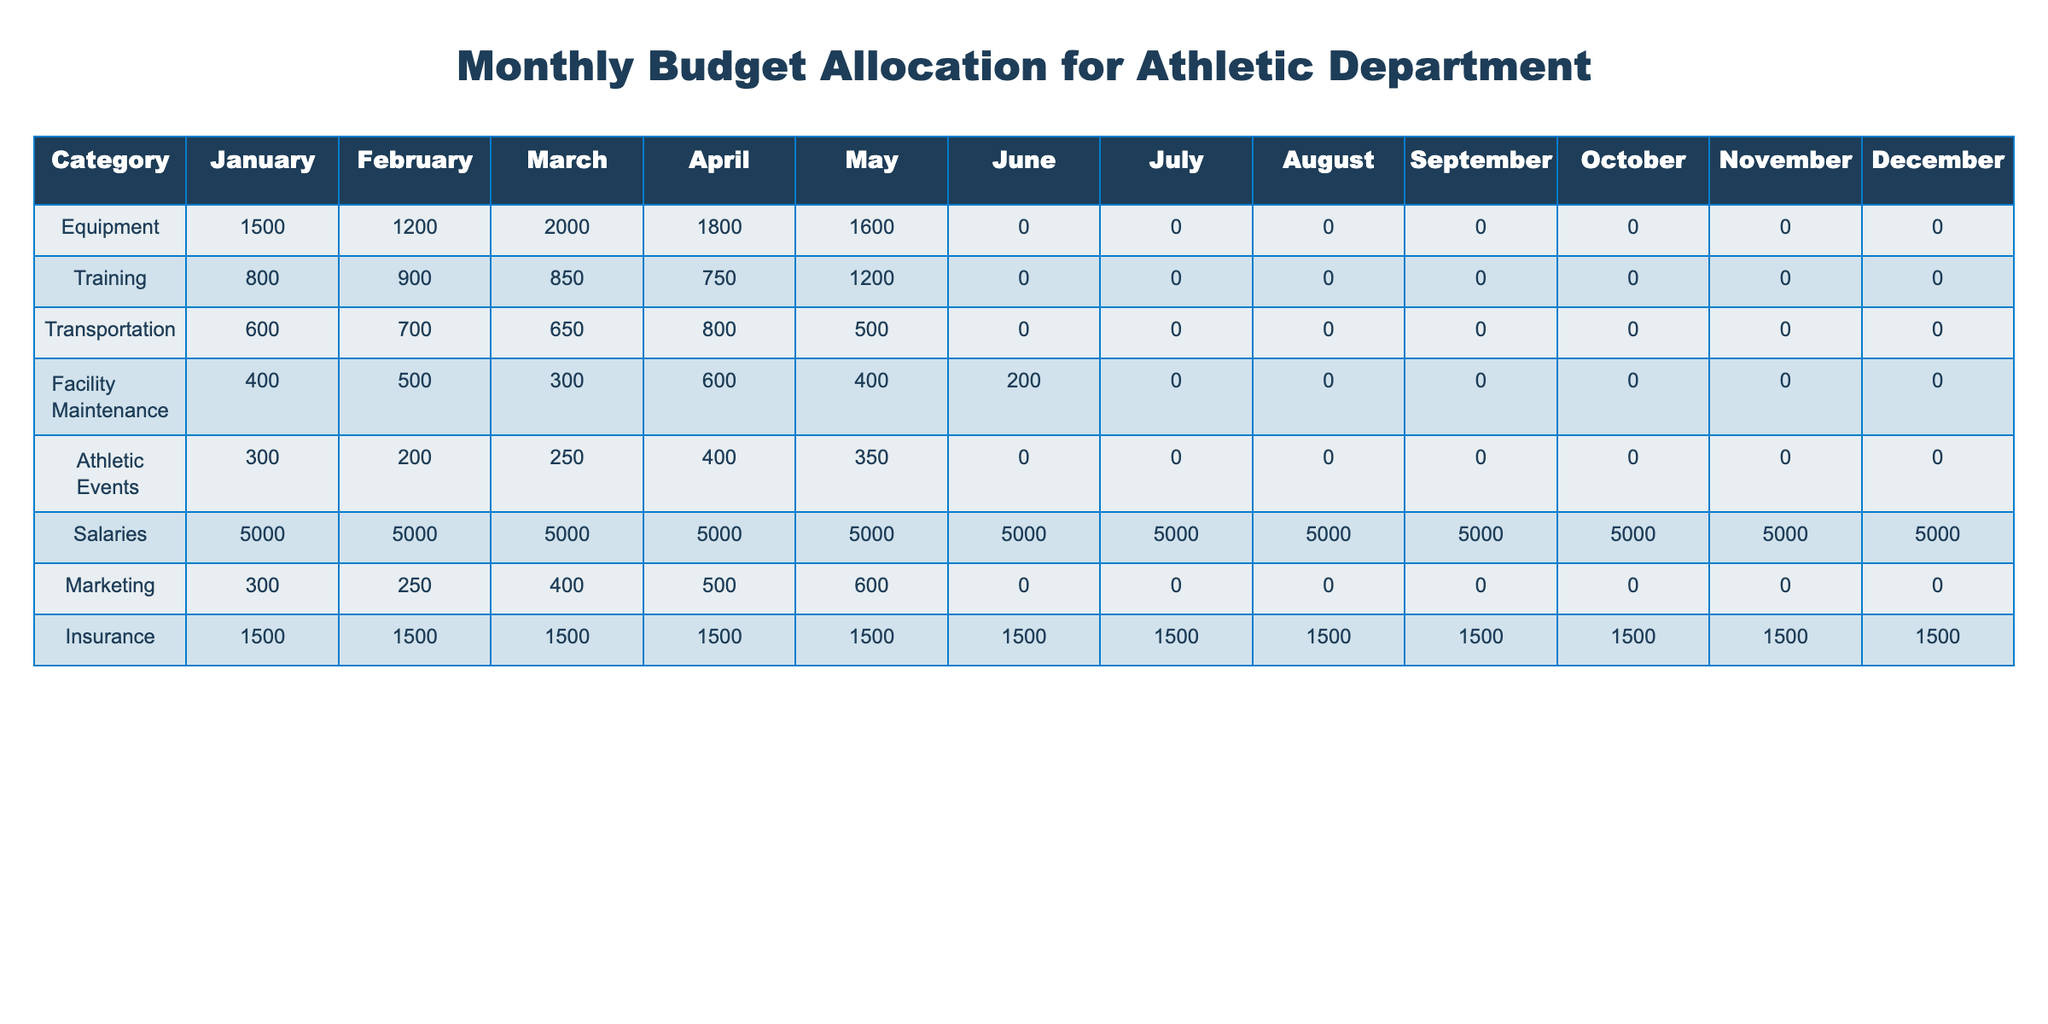What is the total budget allocated for equipment in the month of March? From the "Equipment" row in the March column, the allocated budget is 2000. Therefore, the total budget allocated for equipment in March is 2000.
Answer: 2000 What were the monthly expenditures for facility maintenance in the first quarter (January to March)? For facility maintenance, the expenditures in Q1 are January 400, February 500, and March 300. Adding these values: 400 + 500 + 300 gives 1200.
Answer: 1200 Is the budget for salaries the highest allocation in any month? Since the salary allocation is consistently 5000 for all months, it is indeed the highest allocation compared to other categories, which fluctuate throughout the year.
Answer: Yes Which month has the highest allocation for marketing and what is that amount? Looking through the Marketing row, August has the maximum allocation of 0, while it peaks at 600 in May. Therefore, May is the month with the highest allocation for marketing.
Answer: 600 What is the average monthly budget allocated for transportation over the year? The annual transportation budget totals: January 600, February 700, March 650, April 800, May 500, with the remaining months having 0. Adding these values gives 600 + 700 + 650 + 800 + 500 = 3250. Dividing by the 12 months gives an average of 3250 / 12 = approximately 270.83.
Answer: 270.83 What is the total budget for athletic events from April to June? For athletic events from April to June, the allocations are: April 400, May 350, and June 0. Summing these allocations gives: 400 + 350 + 0 = 750.
Answer: 750 How much more is spent on insurance compared to equipment in May? The insurance allocation in May is 1500, while the equipment allocation is 1600. To find how much more is spent on insurance, we subtract: 1500 - 1600 gives -100, indicating less spent on insurance in May.
Answer: -100 In which month did the training budget see the highest allocation, and what was that amount? By checking the Training row, we can see January has an allocation of 800, February has 900, March has 850, April has 750, and May has 1200. The highest allocation for training is in May at 1200.
Answer: 1200 